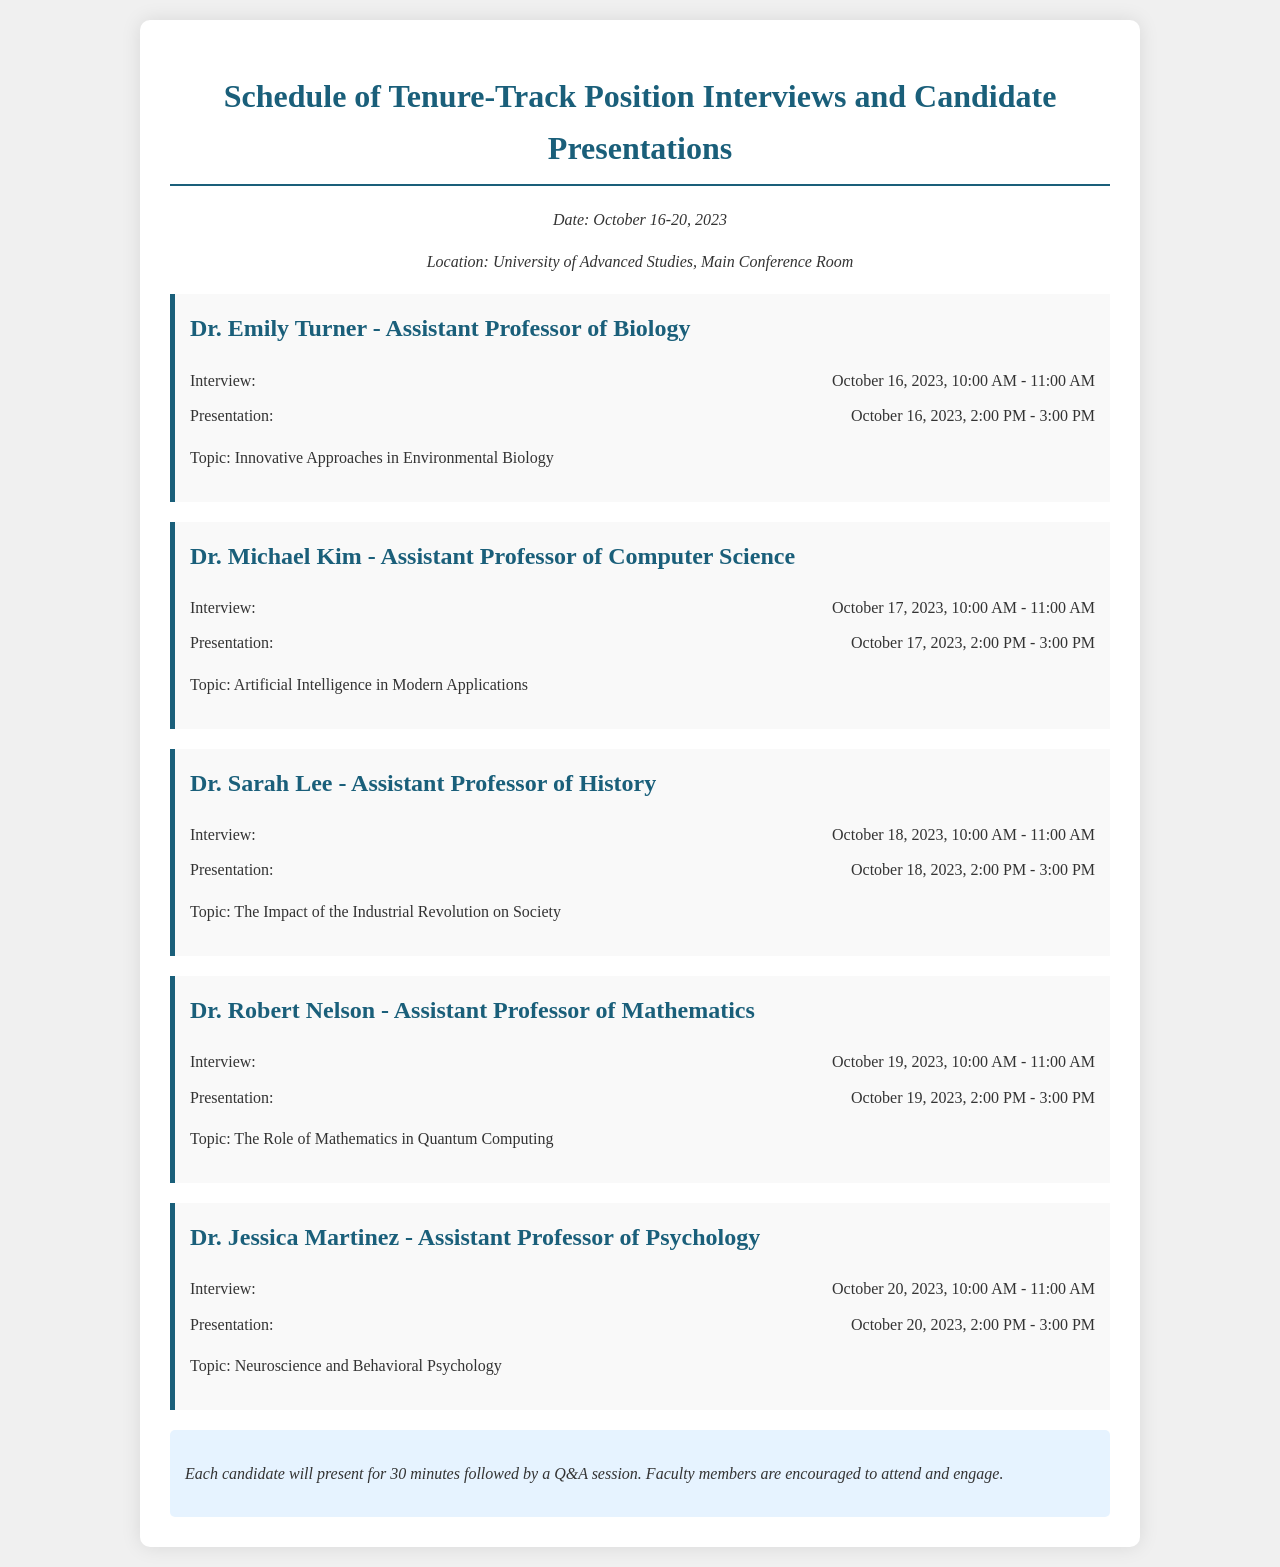what is the date range for the interviews? The document states that the interviews will take place from October 16 to October 20, 2023.
Answer: October 16-20, 2023 who is presenting on October 19, 2023? The document lists Dr. Robert Nelson as the candidate presenting on this date.
Answer: Dr. Robert Nelson what is the topic of Dr. Sarah Lee's presentation? The document specifies that Dr. Sarah Lee will present on "The Impact of the Industrial Revolution on Society."
Answer: The Impact of the Industrial Revolution on Society how long is each presentation? The document informs that each candidate will present for 30 minutes.
Answer: 30 minutes when is Dr. Jessica Martinez's interview scheduled? The document indicates that Dr. Jessica Martinez's interview is on October 20, 2023.
Answer: October 20, 2023 how many candidates are presenting during the schedule? The document lists five candidates participating in the interviews and presentations.
Answer: Five what time does the presentation for Dr. Michael Kim begin? According to the document, Dr. Michael Kim's presentation starts at 2:00 PM on October 17, 2023.
Answer: 2:00 PM where is the location of the interviews? The document states that the location for the interviews is the Main Conference Room at the University of Advanced Studies.
Answer: Main Conference Room what is the common structure of the schedule for presentations? The document notes that each presentation will be followed by a Q&A session.
Answer: A Q&A session 